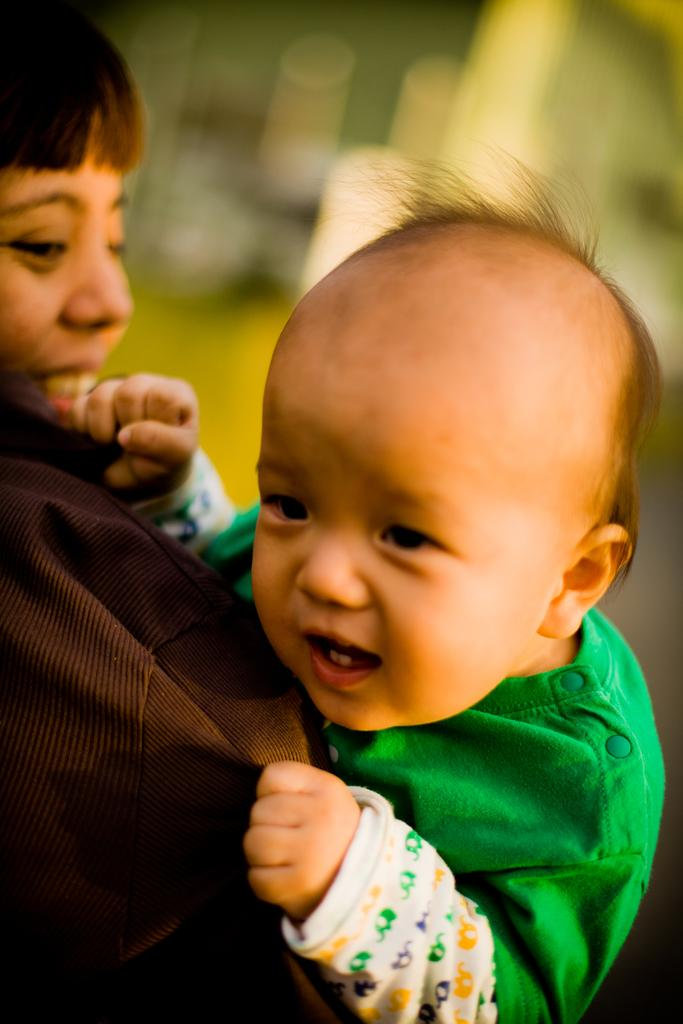Who is the main subject in the foreground of the image? There is a woman in the foreground of the image. What is the woman wearing? The woman is wearing a brown coat. What is the woman doing in the image? The woman is carrying a kid. What is the kid wearing? The kid is wearing a green dress. How would you describe the background of the image? The background of the image is blurred. What type of kettle can be seen in the woman's stomach in the image? There is no kettle present in the image, and the woman's stomach is not visible. 